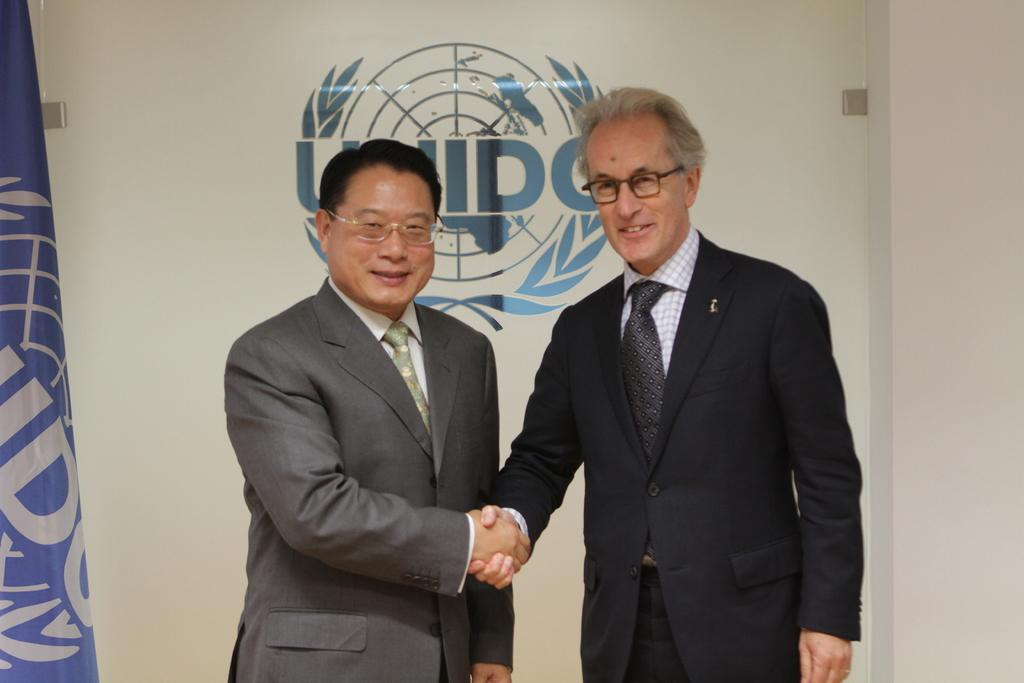How many people are in the image? There are two people standing in the center of the image. What are the two people doing? The two people are shaking hands. What can be seen in the background of the image? There is a wall and a flag in the background of the image. How many apples are on the thumb of the person in the image? There are no apples or thumbs visible in the image; the two people are shaking hands. Is there a prison in the background of the image? There is no prison present in the image; it features a wall and a flag in the background. 